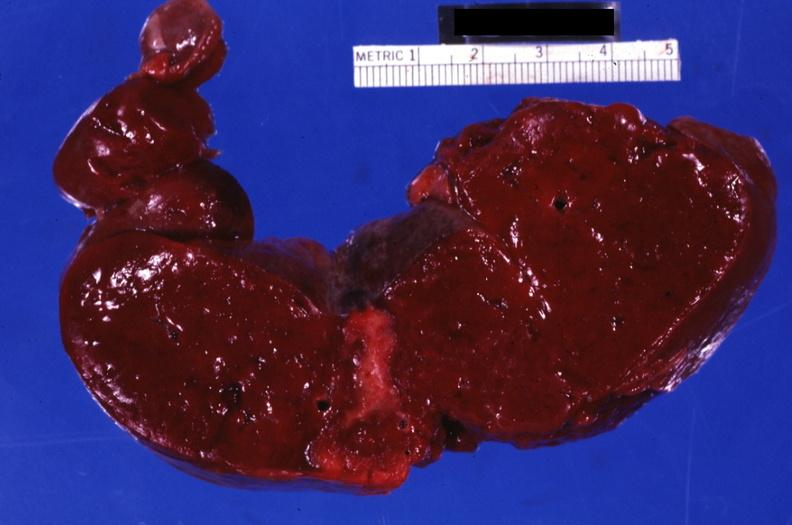does colon show section through spleen with large well shown healing infarct?
Answer the question using a single word or phrase. No 